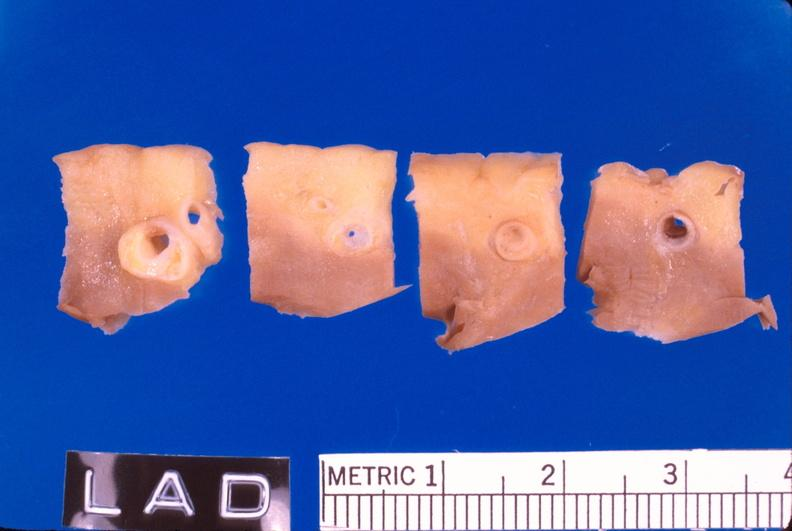s vasculature present?
Answer the question using a single word or phrase. Yes 